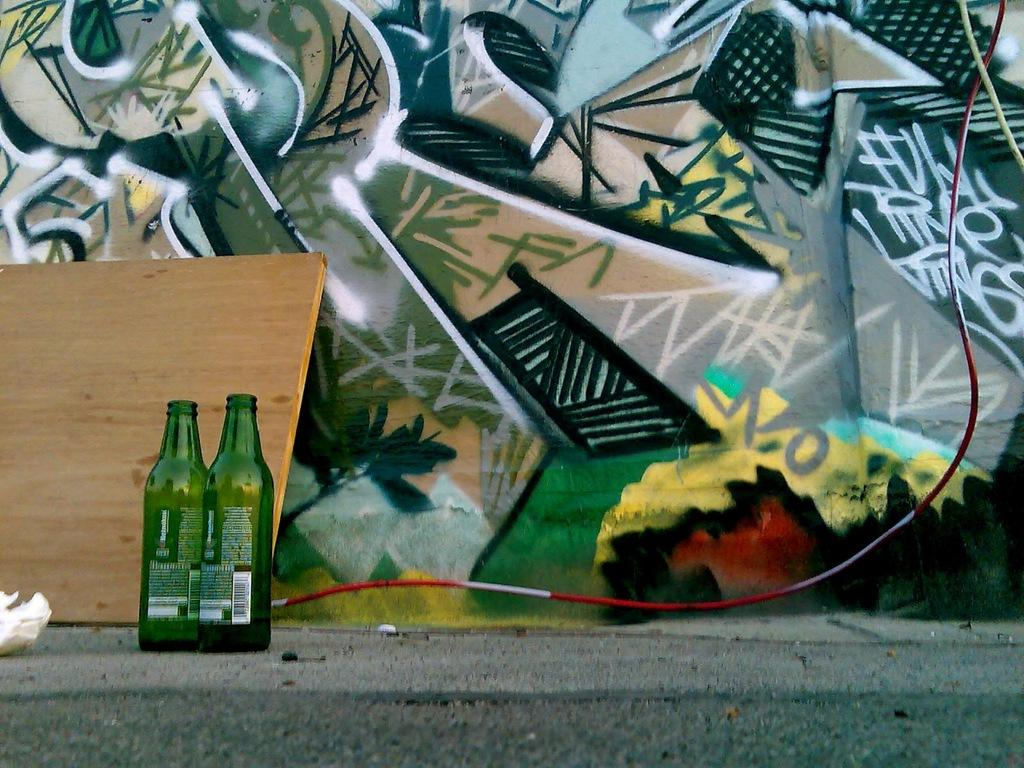What objects are present in the image related to wine? There are two wine bottles in the image. Where are the wine bottles located? The wine bottles are kept on the road. What type of clam is used to open the wine bottles in the image? There are no clams present in the image, and wine bottles are typically opened using a corkscrew, not a clam. 